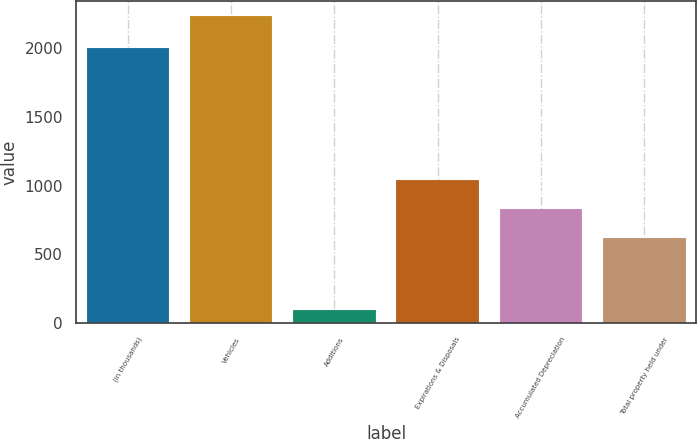<chart> <loc_0><loc_0><loc_500><loc_500><bar_chart><fcel>(in thousands)<fcel>Vehicles<fcel>Additions<fcel>Expirations & Disposals<fcel>Accumulated Depreciation<fcel>Total property held under<nl><fcel>2006<fcel>2234<fcel>92<fcel>1044.4<fcel>830.2<fcel>616<nl></chart> 